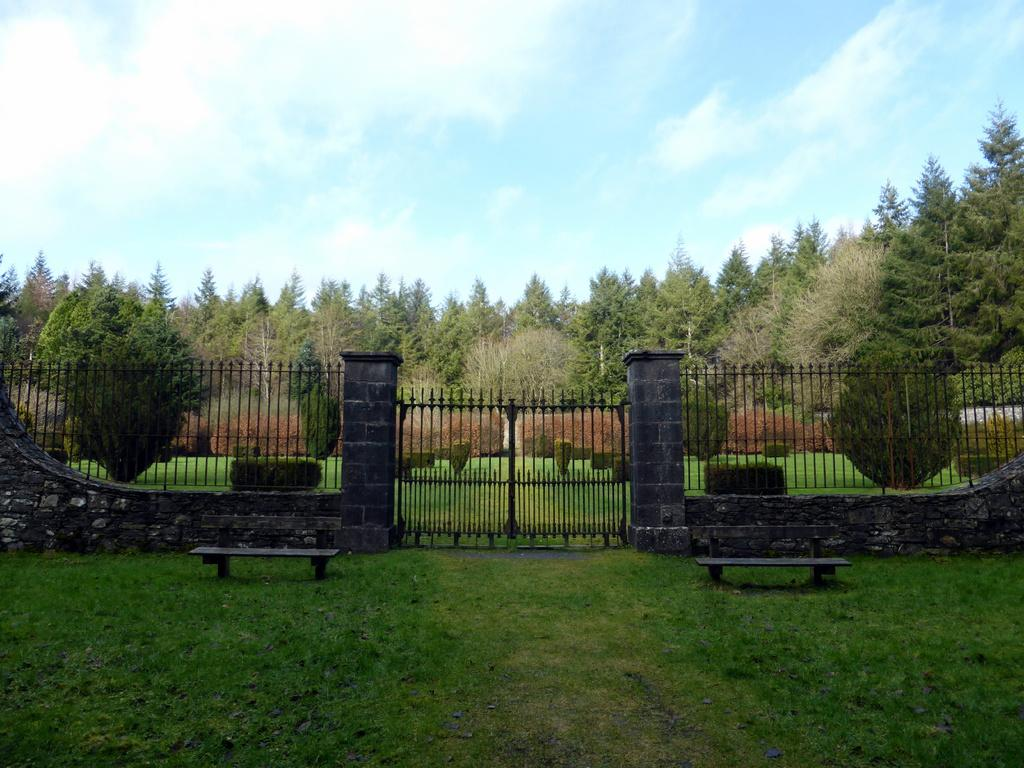What type of seating can be seen in the foreground of the image? There are benches on the grassland in the foreground area of the image. What structure is visible in the background of the image? There is a gate in the background of the image. What else can be seen in the background of the image? There is a boundary and trees present in the background of the image. What part of the natural environment is visible in the background of the image? The sky is visible in the background of the image. What song is being played in the background of the image? There is no information about a song being played in the image. What type of furniture is present in the image? The image does not show any furniture; it features benches, a gate, and trees. 